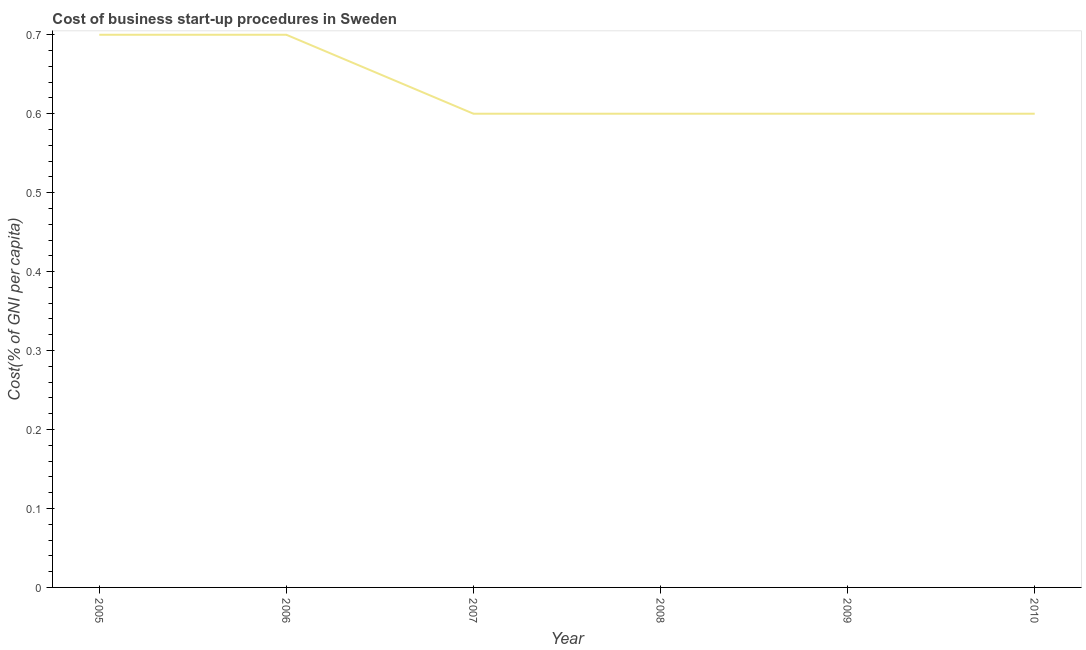What is the cost of business startup procedures in 2006?
Provide a short and direct response. 0.7. Across all years, what is the minimum cost of business startup procedures?
Offer a very short reply. 0.6. In which year was the cost of business startup procedures maximum?
Make the answer very short. 2005. In which year was the cost of business startup procedures minimum?
Offer a very short reply. 2007. What is the sum of the cost of business startup procedures?
Offer a very short reply. 3.8. What is the difference between the cost of business startup procedures in 2005 and 2007?
Offer a very short reply. 0.1. What is the average cost of business startup procedures per year?
Keep it short and to the point. 0.63. In how many years, is the cost of business startup procedures greater than 0.18 %?
Offer a very short reply. 6. Do a majority of the years between 2010 and 2005 (inclusive) have cost of business startup procedures greater than 0.08 %?
Make the answer very short. Yes. What is the ratio of the cost of business startup procedures in 2005 to that in 2006?
Your response must be concise. 1. Is the difference between the cost of business startup procedures in 2005 and 2008 greater than the difference between any two years?
Your answer should be compact. Yes. What is the difference between the highest and the second highest cost of business startup procedures?
Offer a very short reply. 0. Is the sum of the cost of business startup procedures in 2006 and 2009 greater than the maximum cost of business startup procedures across all years?
Provide a succinct answer. Yes. What is the difference between the highest and the lowest cost of business startup procedures?
Keep it short and to the point. 0.1. In how many years, is the cost of business startup procedures greater than the average cost of business startup procedures taken over all years?
Provide a short and direct response. 2. Does the cost of business startup procedures monotonically increase over the years?
Your response must be concise. No. How many years are there in the graph?
Provide a succinct answer. 6. What is the difference between two consecutive major ticks on the Y-axis?
Your answer should be very brief. 0.1. Are the values on the major ticks of Y-axis written in scientific E-notation?
Offer a terse response. No. Does the graph contain any zero values?
Provide a short and direct response. No. Does the graph contain grids?
Ensure brevity in your answer.  No. What is the title of the graph?
Give a very brief answer. Cost of business start-up procedures in Sweden. What is the label or title of the X-axis?
Offer a terse response. Year. What is the label or title of the Y-axis?
Provide a succinct answer. Cost(% of GNI per capita). What is the difference between the Cost(% of GNI per capita) in 2005 and 2007?
Give a very brief answer. 0.1. What is the difference between the Cost(% of GNI per capita) in 2005 and 2009?
Offer a terse response. 0.1. What is the difference between the Cost(% of GNI per capita) in 2006 and 2007?
Give a very brief answer. 0.1. What is the difference between the Cost(% of GNI per capita) in 2006 and 2010?
Give a very brief answer. 0.1. What is the difference between the Cost(% of GNI per capita) in 2007 and 2009?
Provide a succinct answer. 0. What is the difference between the Cost(% of GNI per capita) in 2009 and 2010?
Ensure brevity in your answer.  0. What is the ratio of the Cost(% of GNI per capita) in 2005 to that in 2007?
Offer a terse response. 1.17. What is the ratio of the Cost(% of GNI per capita) in 2005 to that in 2008?
Offer a terse response. 1.17. What is the ratio of the Cost(% of GNI per capita) in 2005 to that in 2009?
Your answer should be very brief. 1.17. What is the ratio of the Cost(% of GNI per capita) in 2005 to that in 2010?
Provide a succinct answer. 1.17. What is the ratio of the Cost(% of GNI per capita) in 2006 to that in 2007?
Give a very brief answer. 1.17. What is the ratio of the Cost(% of GNI per capita) in 2006 to that in 2008?
Provide a succinct answer. 1.17. What is the ratio of the Cost(% of GNI per capita) in 2006 to that in 2009?
Your response must be concise. 1.17. What is the ratio of the Cost(% of GNI per capita) in 2006 to that in 2010?
Give a very brief answer. 1.17. What is the ratio of the Cost(% of GNI per capita) in 2007 to that in 2008?
Provide a succinct answer. 1. What is the ratio of the Cost(% of GNI per capita) in 2007 to that in 2010?
Your answer should be compact. 1. 